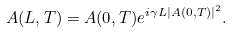Convert formula to latex. <formula><loc_0><loc_0><loc_500><loc_500>A ( L , T ) = A ( 0 , T ) e ^ { i \gamma L | A ( 0 , T ) | ^ { 2 } } .</formula> 